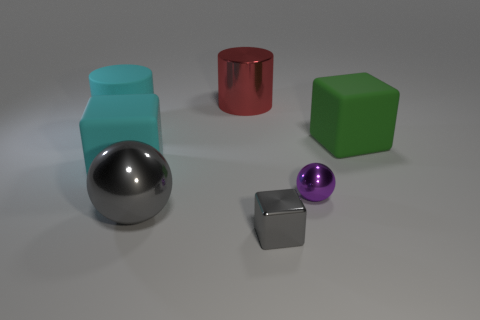Subtract all cyan blocks. How many blocks are left? 2 Add 1 small purple things. How many objects exist? 8 Subtract all cyan blocks. How many blocks are left? 2 Subtract all spheres. How many objects are left? 5 Subtract all green cylinders. How many gray cubes are left? 1 Add 7 large cyan objects. How many large cyan objects are left? 9 Add 4 big purple cubes. How many big purple cubes exist? 4 Subtract 0 red spheres. How many objects are left? 7 Subtract 1 spheres. How many spheres are left? 1 Subtract all red cylinders. Subtract all brown spheres. How many cylinders are left? 1 